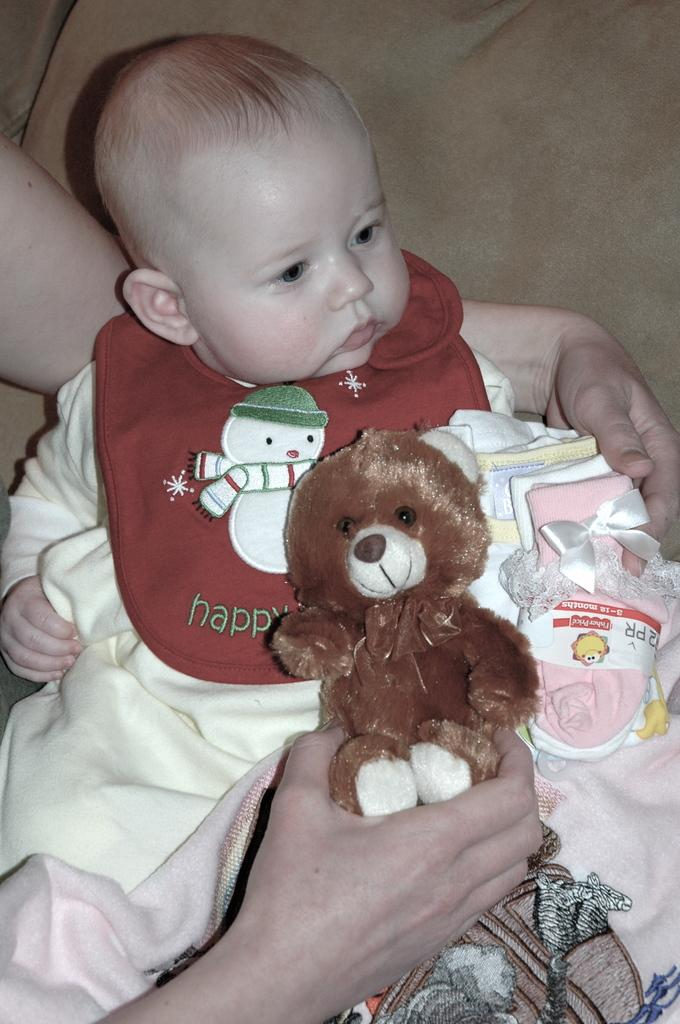Who is present in the image? There is a person in the image. What is the person doing in the image? The person is carrying a baby and holding a toy. What direction is the baby looking in the image? The baby is looking to the right side. What type of seat is the baby sitting on in the image? The baby is not sitting on a seat in the image; they are being carried by the person. 